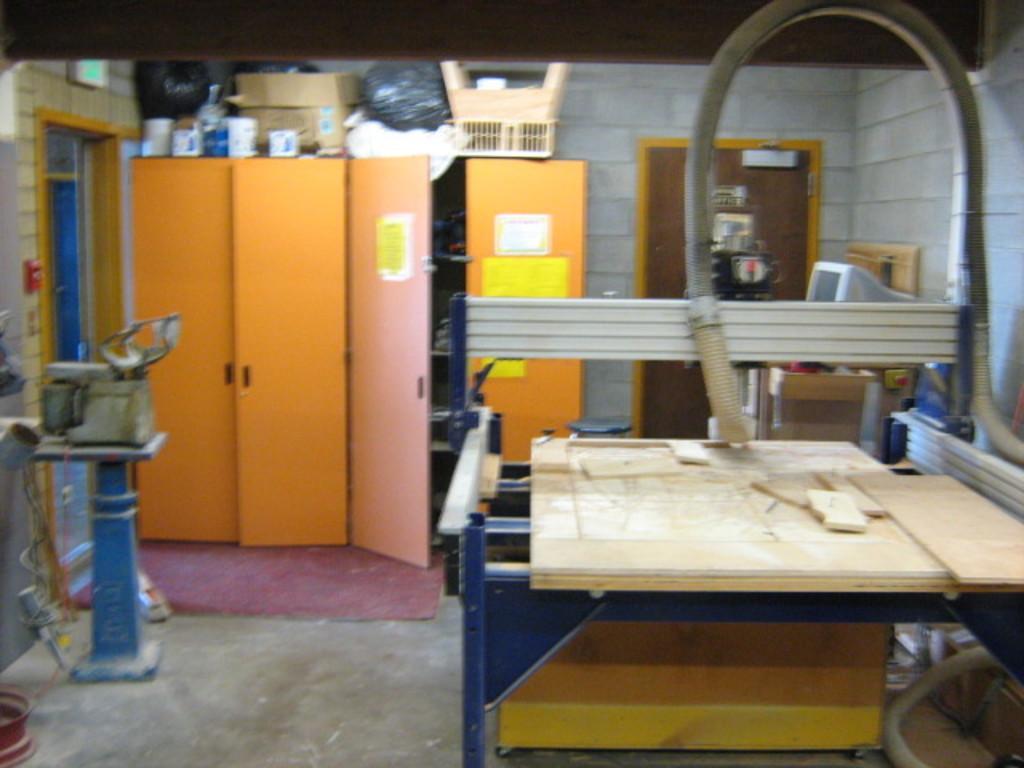How would you summarize this image in a sentence or two? In this picture, there is a table towards the right. On the table, there is a pipe. In the center, there are cupboards. Beside it, there is a door. On the cupboards, there are some objects. Towards the left, there is a device. 